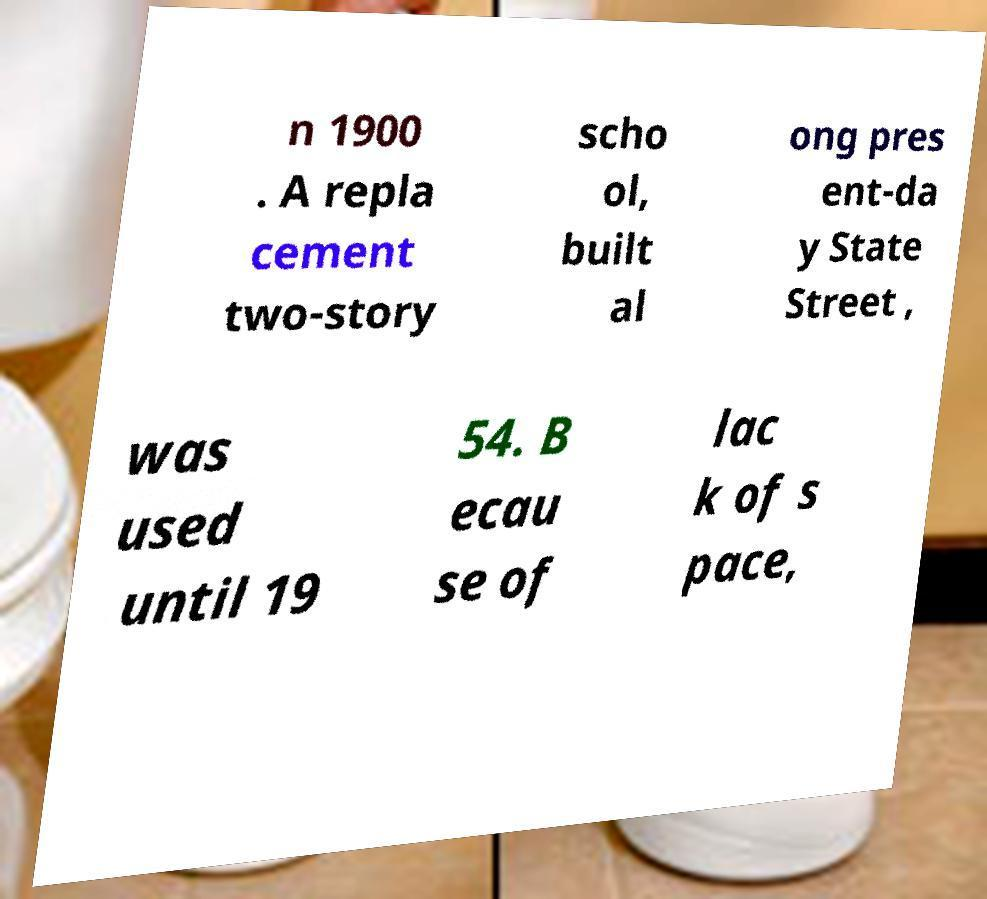Please read and relay the text visible in this image. What does it say? n 1900 . A repla cement two-story scho ol, built al ong pres ent-da y State Street , was used until 19 54. B ecau se of lac k of s pace, 